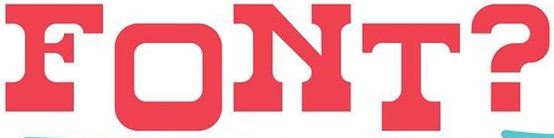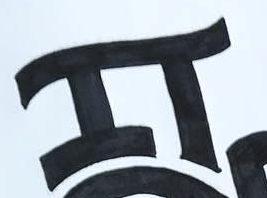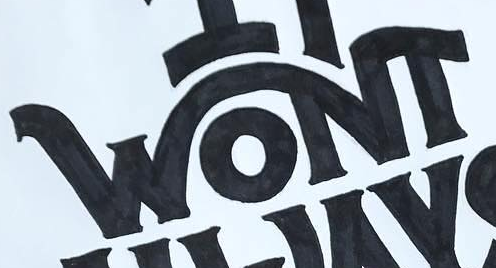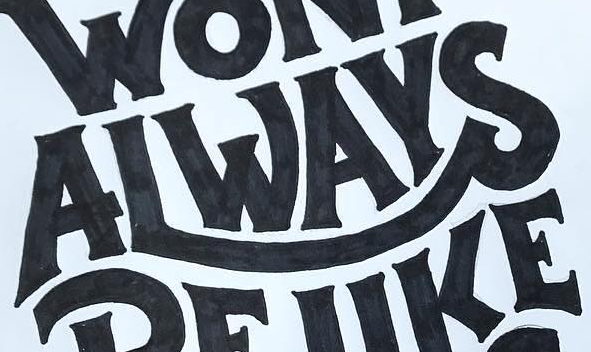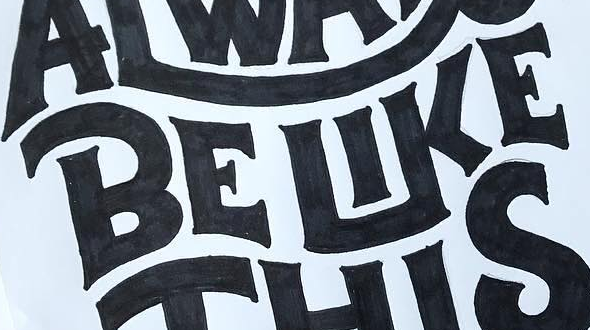Identify the words shown in these images in order, separated by a semicolon. FONT?; IT; WONT; ALWAYS; BELIKE 